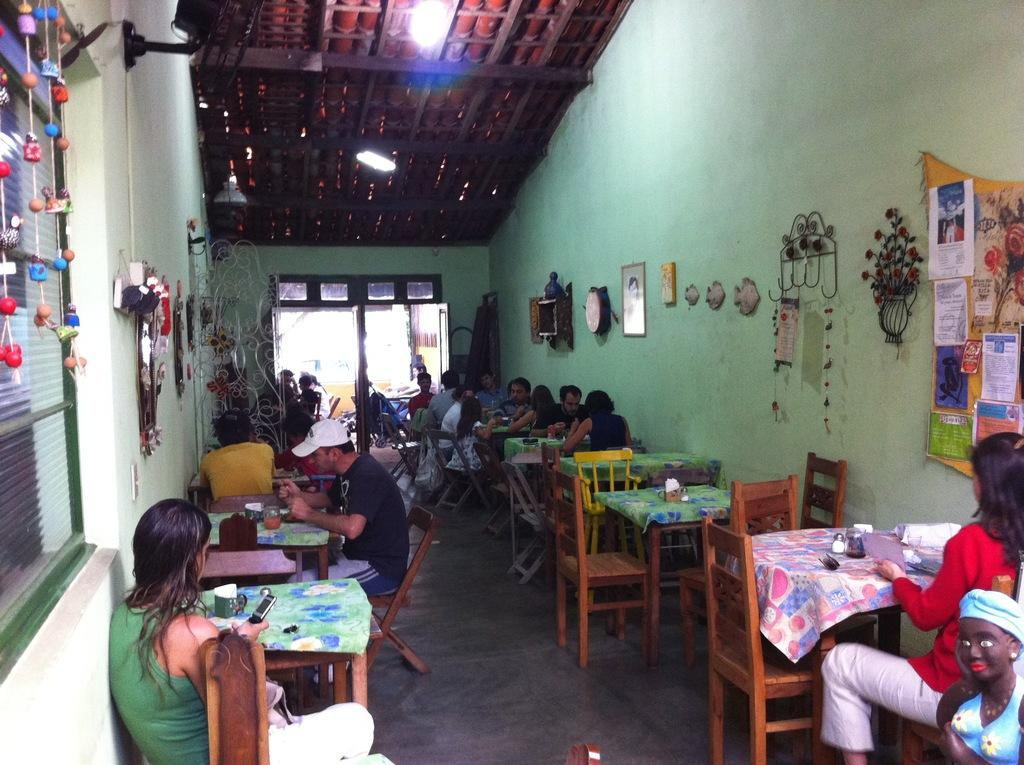What are the people in the image doing? There is a group of people sitting on chairs in the image. What object can be seen on the table? There is a tissue holder on the table in the image. What is hanging on the wall? There are frames on the wall in the image. What type of leather material is covering the chairs in the image? There is no mention of leather or any specific material covering the chairs in the image. 